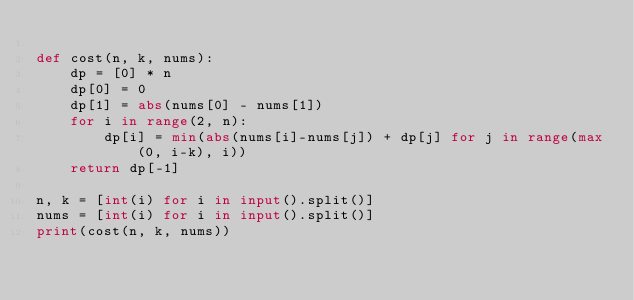<code> <loc_0><loc_0><loc_500><loc_500><_Python_>
def cost(n, k, nums):
    dp = [0] * n
    dp[0] = 0
    dp[1] = abs(nums[0] - nums[1])
    for i in range(2, n):
        dp[i] = min(abs(nums[i]-nums[j]) + dp[j] for j in range(max(0, i-k), i))
    return dp[-1]

n, k = [int(i) for i in input().split()]
nums = [int(i) for i in input().split()]
print(cost(n, k, nums))</code> 